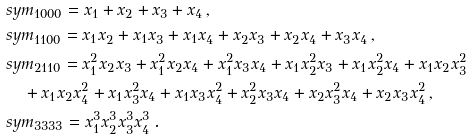Convert formula to latex. <formula><loc_0><loc_0><loc_500><loc_500>& s y m _ { 1 0 0 0 } = x _ { 1 } + x _ { 2 } + x _ { 3 } + x _ { 4 } \, , \\ & s y m _ { 1 1 0 0 } = x _ { 1 } x _ { 2 } + x _ { 1 } x _ { 3 } + x _ { 1 } x _ { 4 } + x _ { 2 } x _ { 3 } + x _ { 2 } x _ { 4 } + x _ { 3 } x _ { 4 } \, , \\ & s y m _ { 2 1 1 0 } = x _ { 1 } ^ { 2 } x _ { 2 } x _ { 3 } + x _ { 1 } ^ { 2 } x _ { 2 } x _ { 4 } + x _ { 1 } ^ { 2 } x _ { 3 } x _ { 4 } + x _ { 1 } x _ { 2 } ^ { 2 } x _ { 3 } + x _ { 1 } x _ { 2 } ^ { 2 } x _ { 4 } + x _ { 1 } x _ { 2 } x _ { 3 } ^ { 2 } \\ & \quad + x _ { 1 } x _ { 2 } x _ { 4 } ^ { 2 } + x _ { 1 } x _ { 3 } ^ { 2 } x _ { 4 } + x _ { 1 } x _ { 3 } x _ { 4 } ^ { 2 } + x _ { 2 } ^ { 2 } x _ { 3 } x _ { 4 } + x _ { 2 } x _ { 3 } ^ { 2 } x _ { 4 } + x _ { 2 } x _ { 3 } x _ { 4 } ^ { 2 } \, , \\ & s y m _ { 3 3 3 3 } = x _ { 1 } ^ { 3 } x _ { 2 } ^ { 3 } x _ { 3 } ^ { 3 } x _ { 4 } ^ { 3 } \, .</formula> 